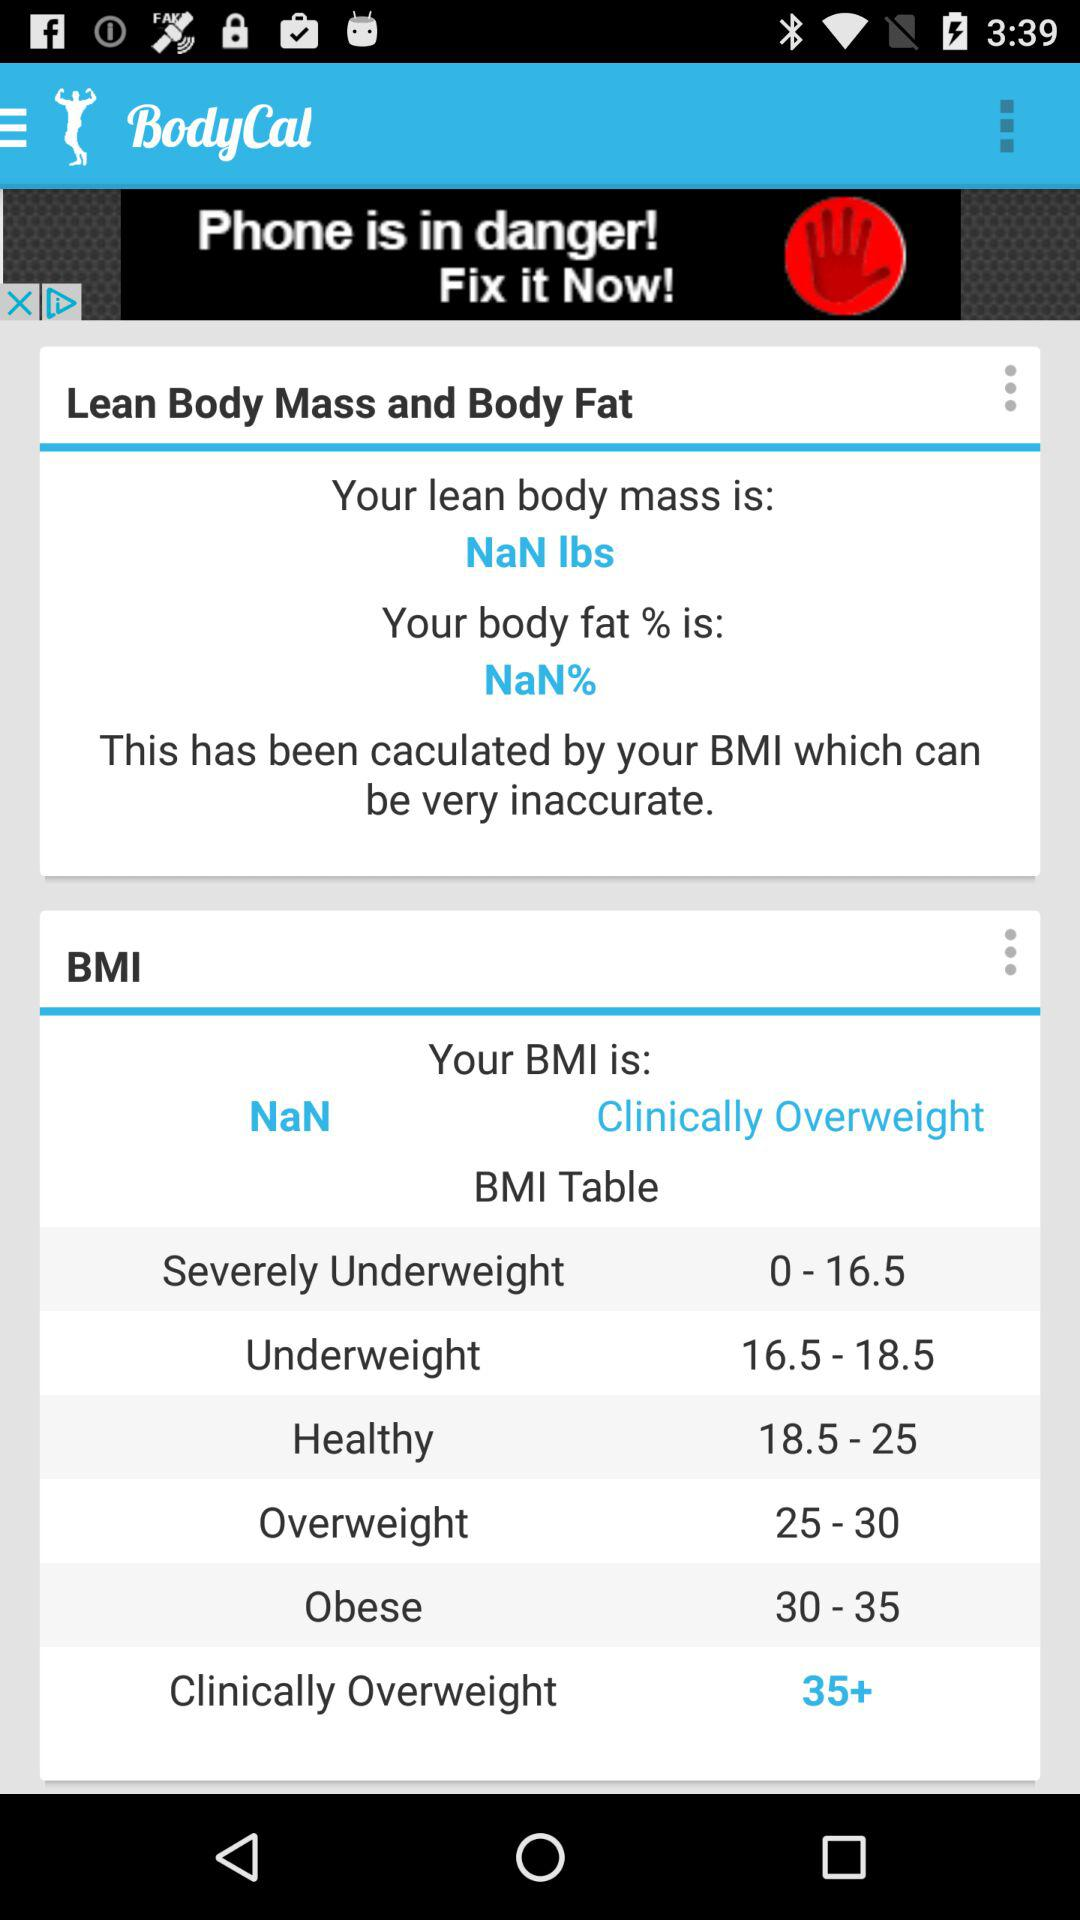What is the range for underweight? The range for underweight is from 16.5 to 18.5. 